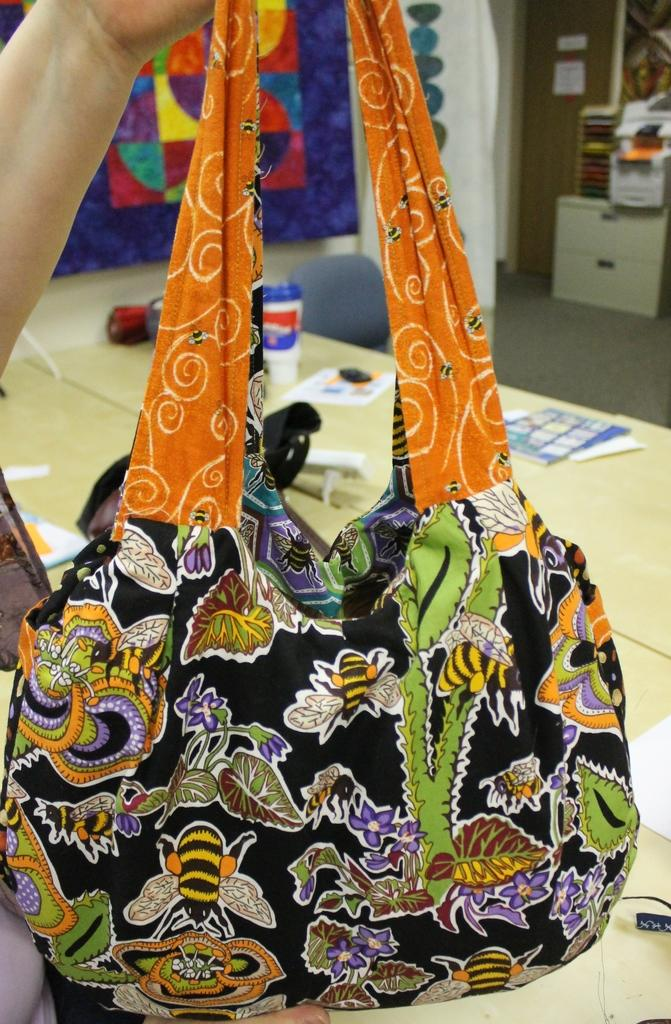What is the main subject of the image? There is a person in the image. What is the person holding in the image? The person is holding a woman's handbag. What type of arithmetic problem can be seen written on the bushes in the image? There are no bushes or arithmetic problems present in the image. What is the person's hope for the future, as depicted in the image? The image does not provide any information about the person's hopes for the future. 